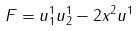<formula> <loc_0><loc_0><loc_500><loc_500>F = u _ { 1 } ^ { 1 } u _ { 2 } ^ { 1 } - 2 x ^ { 2 } u ^ { 1 }</formula> 